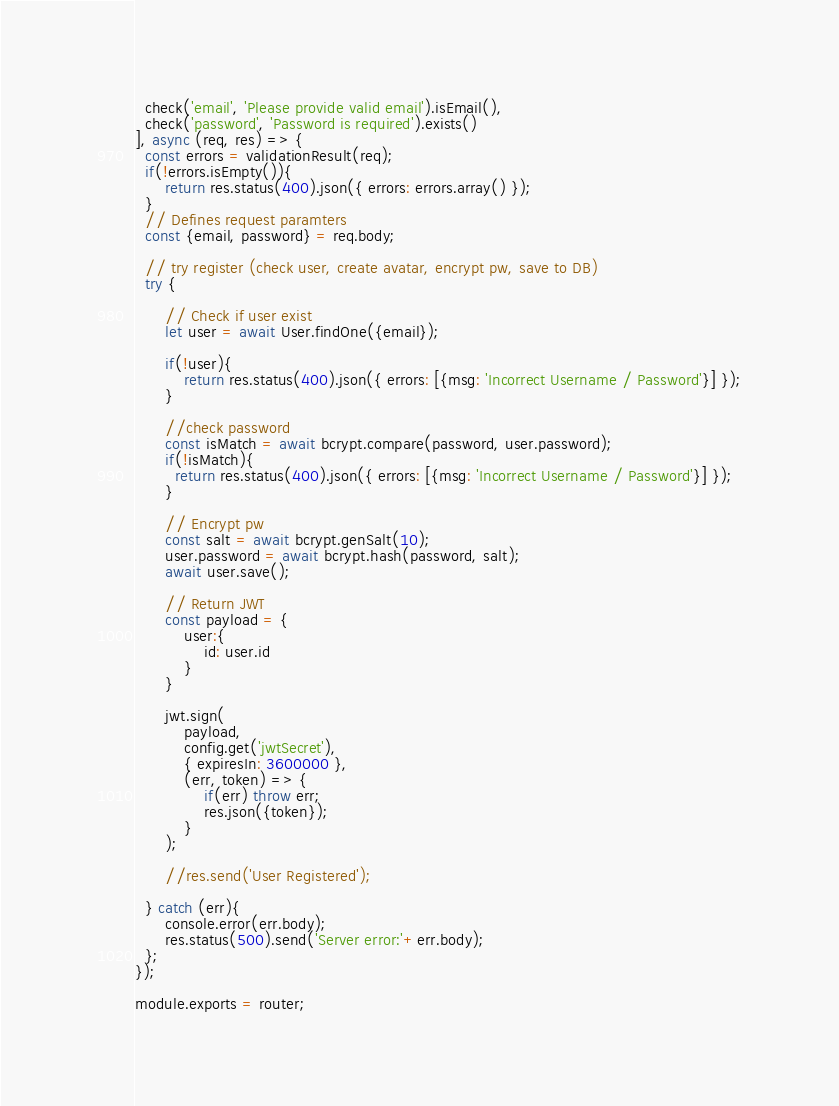<code> <loc_0><loc_0><loc_500><loc_500><_JavaScript_>  check('email', 'Please provide valid email').isEmail(),
  check('password', 'Password is required').exists()
], async (req, res) => {
  const errors = validationResult(req);
  if(!errors.isEmpty()){
      return res.status(400).json({ errors: errors.array() });
  }
  // Defines request paramters
  const {email, password} = req.body;

  // try register (check user, create avatar, encrypt pw, save to DB)
  try {
      
      // Check if user exist
      let user = await User.findOne({email});
      
      if(!user){
          return res.status(400).json({ errors: [{msg: 'Incorrect Username / Password'}] });
      }

      //check password
      const isMatch = await bcrypt.compare(password, user.password);
      if(!isMatch){
        return res.status(400).json({ errors: [{msg: 'Incorrect Username / Password'}] });
      }

      // Encrypt pw
      const salt = await bcrypt.genSalt(10);
      user.password = await bcrypt.hash(password, salt);
      await user.save();

      // Return JWT
      const payload = {
          user:{
              id: user.id
          }
      }

      jwt.sign(
          payload, 
          config.get('jwtSecret'),
          { expiresIn: 3600000 },
          (err, token) => {
              if(err) throw err;
              res.json({token});
          }
      );

      //res.send('User Registered');
      
  } catch (err){
      console.error(err.body);
      res.status(500).send('Server error:'+err.body);
  };
});

module.exports = router;</code> 